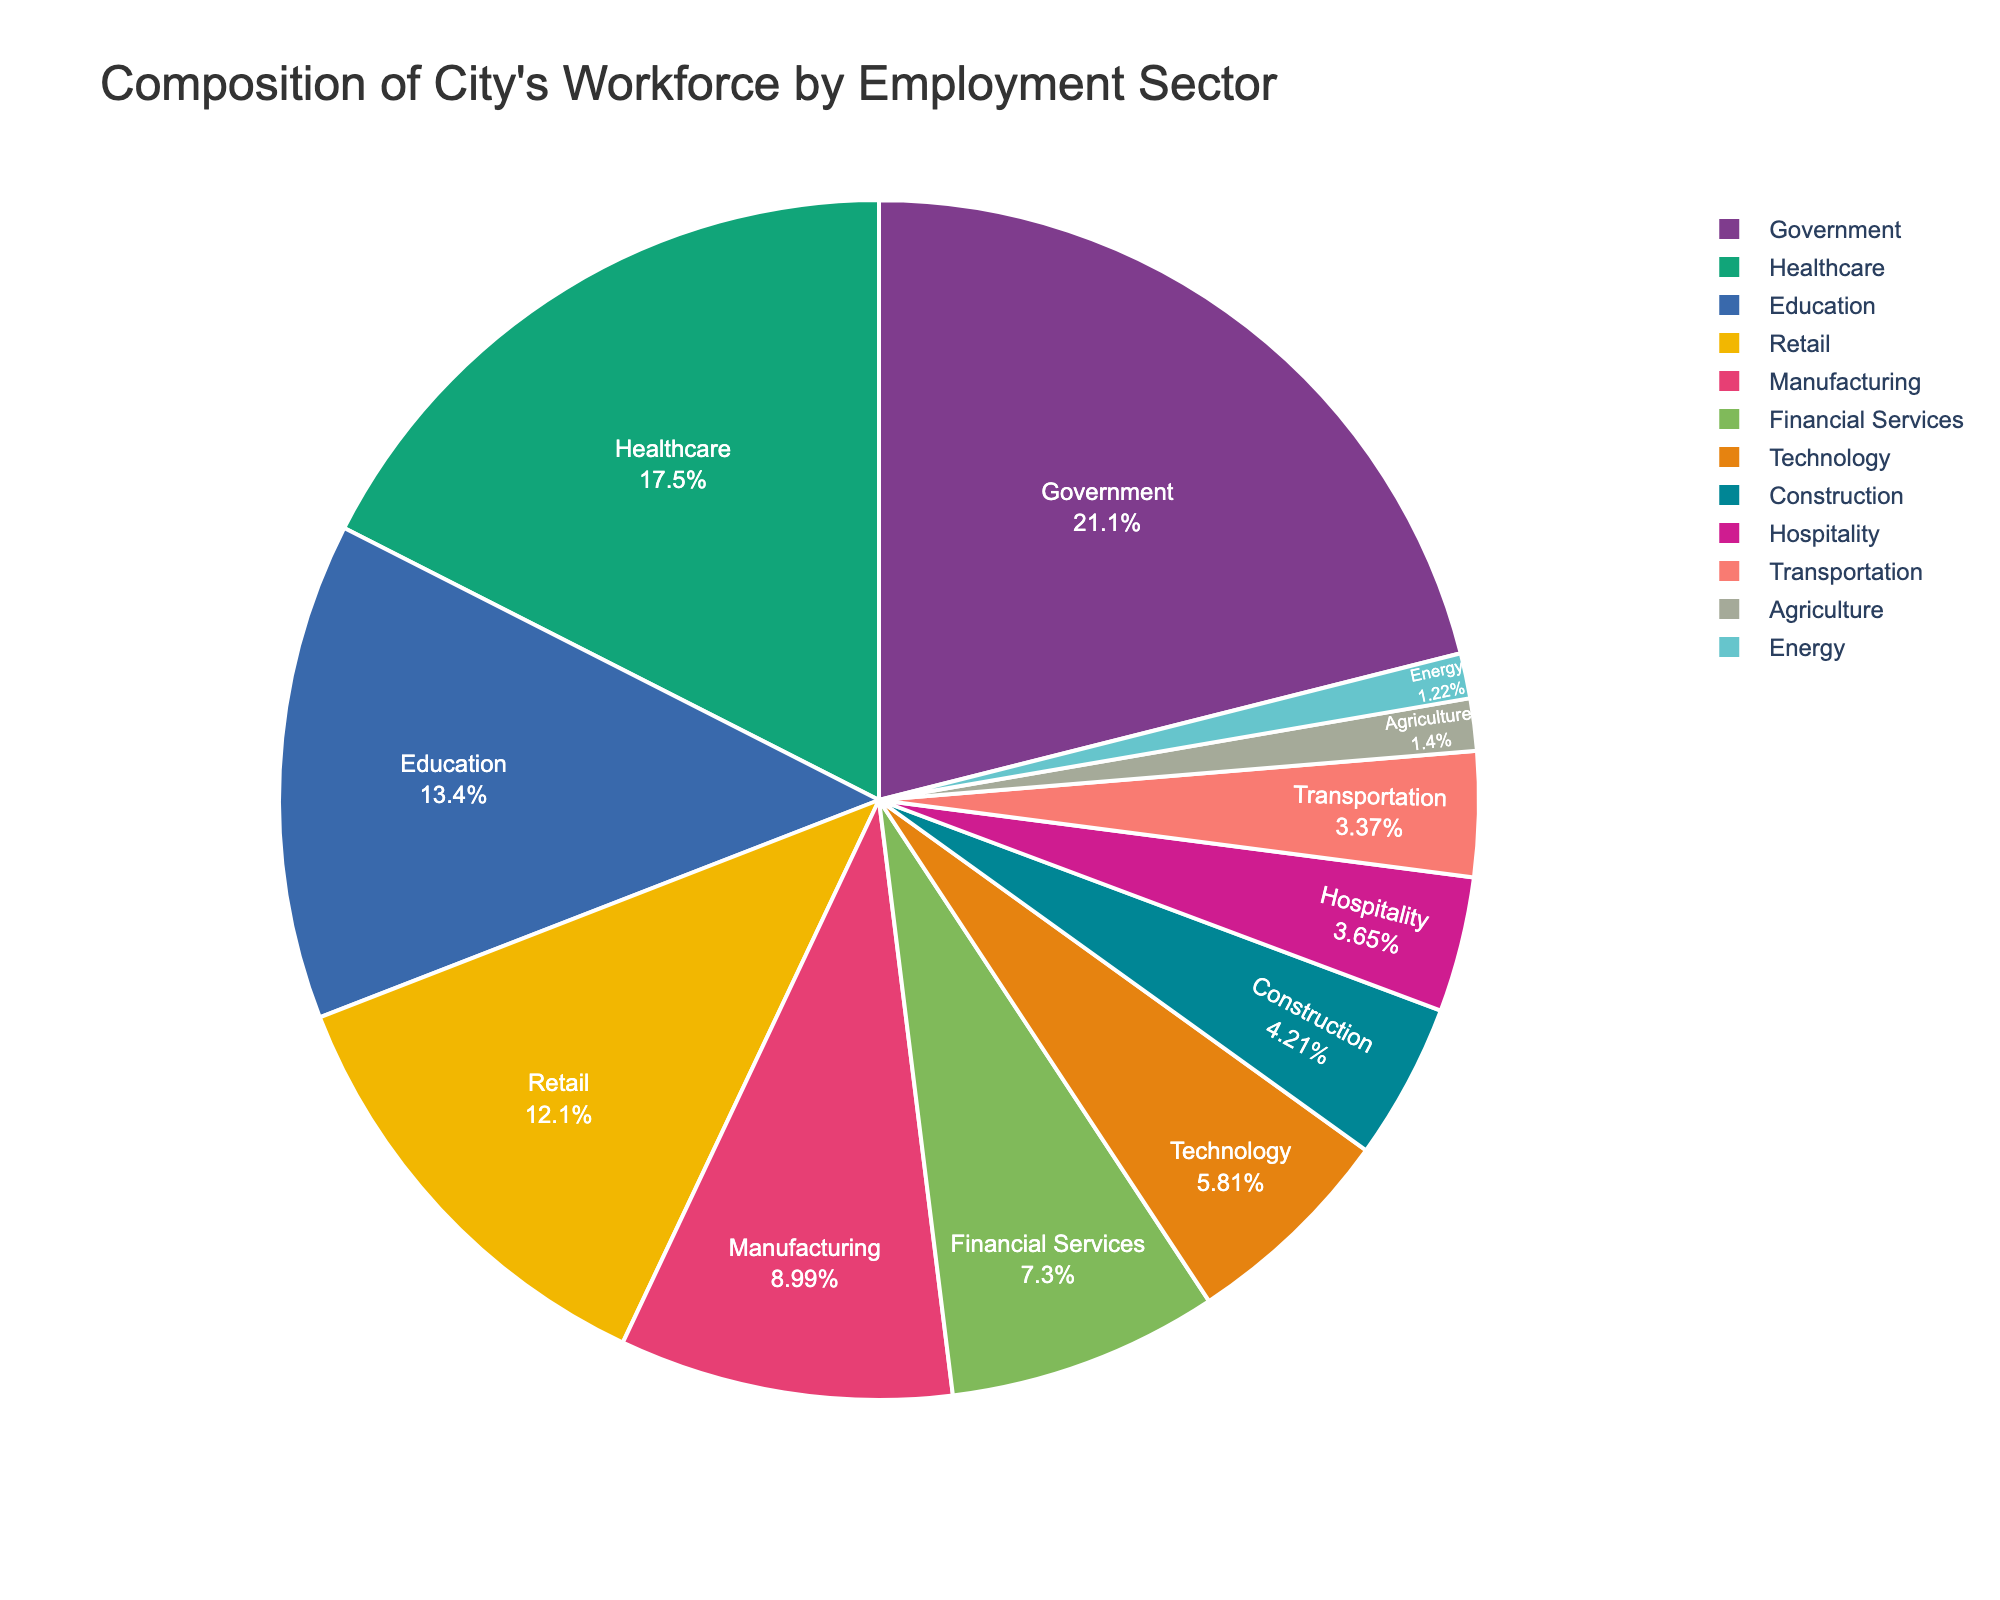What's the sum of the percentages for the Government, Healthcare, and Education sectors? Add the percentages for Government (22.5%), Healthcare (18.7%), and Education (14.3%): 22.5 + 18.7 + 14.3. The result is 55.5%.
Answer: 55.5% Which sector has the lowest percentage, and what is it? Look at the pie chart and identify the sector with the smallest slice. Agriculture has the smallest slice, representing 1.5%.
Answer: Agriculture, 1.5% Is the percentage of the Technology sector greater than the percentage of the Manufacturing sector? Compare the percentages: Technology is 6.2%, and Manufacturing is 9.6%. 6.2% is less than 9.6%.
Answer: No How much more significant is the Government sector compared to the Energy sector in terms of percentage? Subtract the percentage of the Energy sector (1.3%) from the Government sector (22.5%): 22.5 - 1.3 = 21.2%.
Answer: 21.2% What is the combined percentage for the Retail, Hospitality, and Construction sectors? Add the percentages for Retail (12.9%), Hospitality (3.9%), and Construction (4.5%): 12.9 + 3.9 + 4.5. The result is 21.3%.
Answer: 21.3% Which sector is represented with a green slice, and what is its percentage? Identify the slice color associated with green for the given sectors. Typically, colors are assigned to larger sectors first; we should look at one of the major sectors potentially using green: Government (22.5%). Verify visually with the pie chart.
Answer: Government, 22.5% Is the sum of the Transportation and Agriculture sectors greater than the Financial Services sector? Add Transportation (3.6%) and Agriculture (1.5%): 3.6 + 1.5 = 5.1%. Compare this with the Financial Services sector (7.8%). 5.1% is less than 7.8%.
Answer: No Which two sectors have a combined percentage closest to 20% without exceeding it? Check pairs systematically: 
Healthcare (18.7%) is close but a bit too much on its own. Education (14.3%) plus Agriculture (1.5%) = 15.8%; Construction (4.5%) plus Retail (12.9%) = 17.4%. Combine other sectors: Construction (4.5%) and Transportation (3.6%) = 8.1% 
The closest sum under 20% is Retail and Manufacturing (12.9% + 9.6% = 22.5% >, therefore not valid), finally verify Financial Services (7.8%) and another small sector. For example, Technology (6.2%) plus Construction (4.5%) = 10.7% still under. Cloud rounded: adding carefully verified, Hospitality (3.9%) and Energy (1.3%) can be added.
Answer: Education (14.3%) and Energy (1.3%); total close 15.8% valid What is the difference in percentage points between the largest and smallest sectors? Subtract the percentage of the smallest sector (Energy, 1.3%) from the largest sector (Government, 22.5%): 22.5 - 1.3 = 21.2%.
Answer: 21.2% How much less is the Financial Services sector compared to the Healthcare sector? Subtract the percentage of the Financial Services sector (7.8%) from the Healthcare sector (18.7%): 18.7 - 7.8 = 10.9%.
Answer: 10.9% 